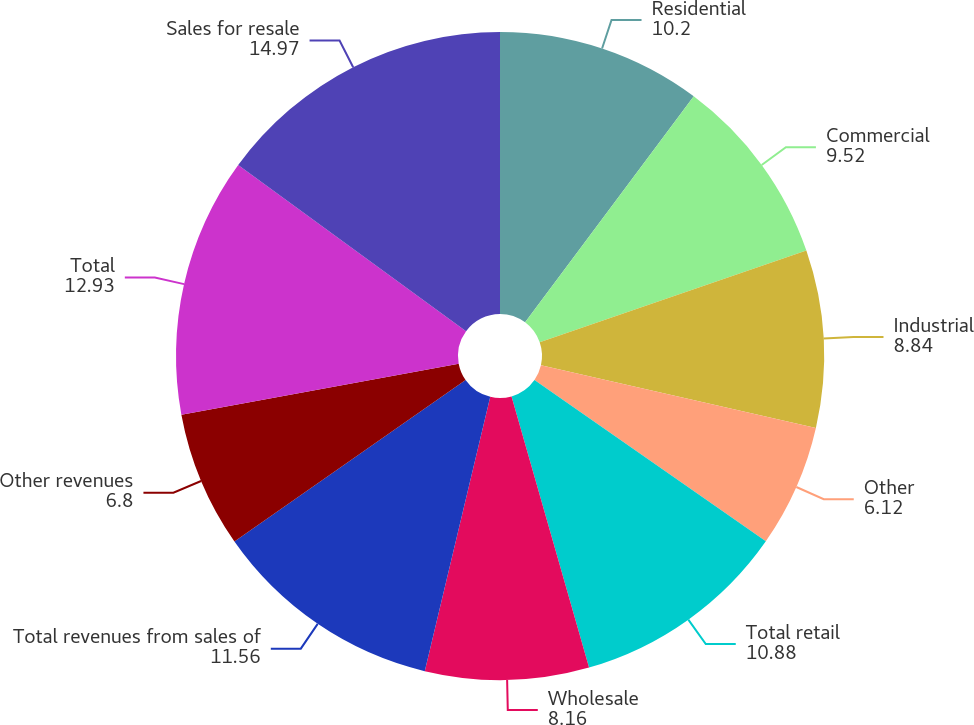Convert chart. <chart><loc_0><loc_0><loc_500><loc_500><pie_chart><fcel>Residential<fcel>Commercial<fcel>Industrial<fcel>Other<fcel>Total retail<fcel>Wholesale<fcel>Total revenues from sales of<fcel>Other revenues<fcel>Total<fcel>Sales for resale<nl><fcel>10.2%<fcel>9.52%<fcel>8.84%<fcel>6.12%<fcel>10.88%<fcel>8.16%<fcel>11.56%<fcel>6.8%<fcel>12.93%<fcel>14.97%<nl></chart> 